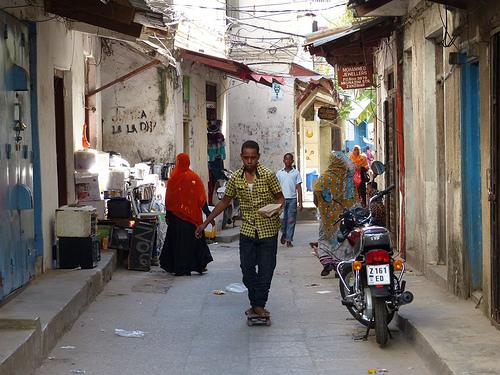Describe one person in the image and their attire, then mention one activity they're engaged in. A man wearing a checkered shirt and jeans is walking down the street. Describe the scene happening in the image, including the people and objects involved. In the scene, a man is walking down a narrow street, a woman in an orange dress is walking behind him, and there are parked motorbikes and bicycles along the street. Based on the image, describe the atmosphere of the location. The narrow street has a calm atmosphere with a few people walking and typical street elements like parked motorbikes and bicycles. Identify the main activity happening in the image and mention the person involved. A man is walking down a narrow street. What is the most eye-catching color in the image and which subject is it associated with? Orange is the eye-catching color and it's associated with the dress of a woman walking in the street. 